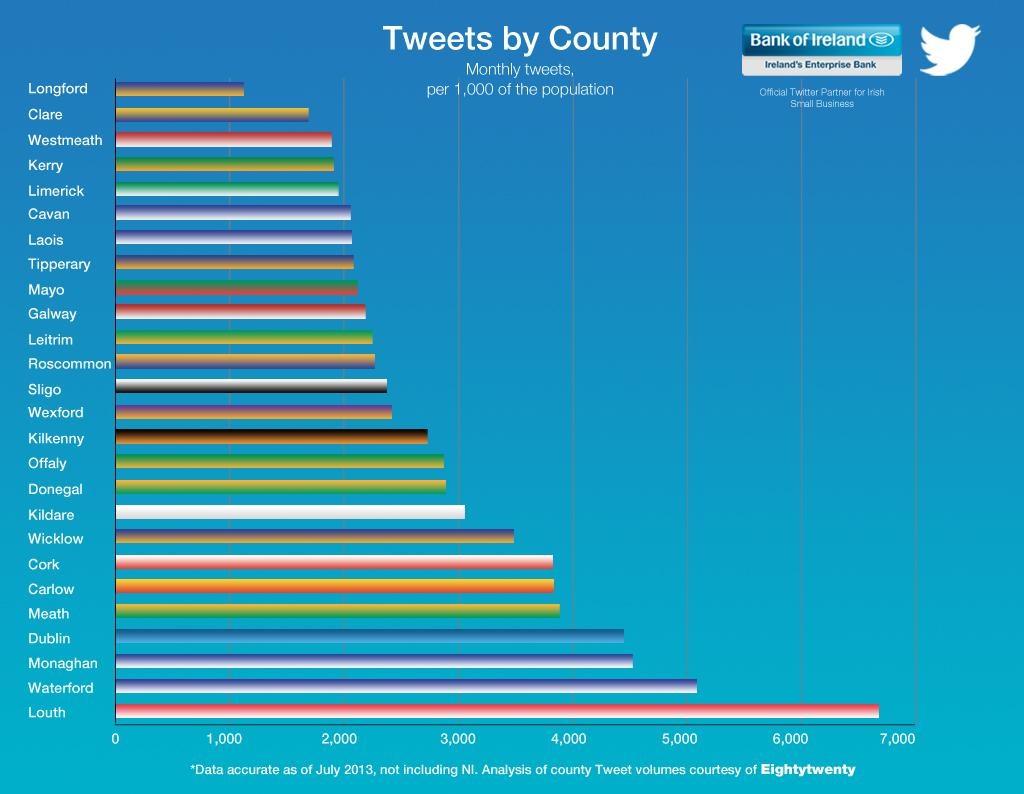Mention a couple of crucial points in this snapshot. Counties Cork and Carlow have the third and fourth highest number of tweets, respectively, after County Meath. Waterford county has the second highest number of tweets. 